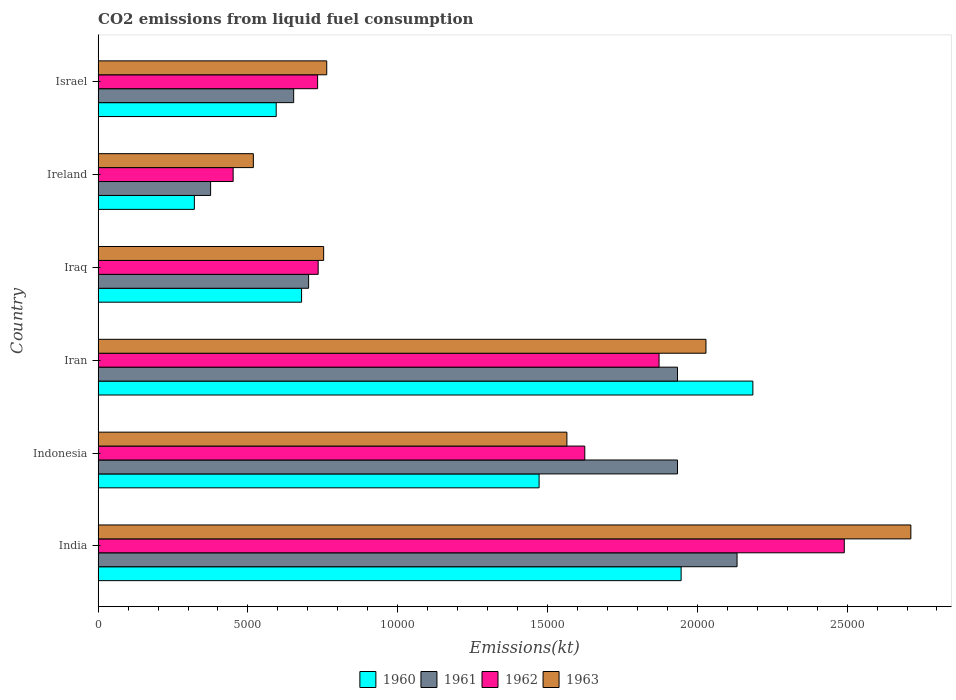How many different coloured bars are there?
Offer a very short reply. 4. How many groups of bars are there?
Provide a short and direct response. 6. How many bars are there on the 6th tick from the top?
Ensure brevity in your answer.  4. What is the label of the 4th group of bars from the top?
Offer a very short reply. Iran. In how many cases, is the number of bars for a given country not equal to the number of legend labels?
Give a very brief answer. 0. What is the amount of CO2 emitted in 1962 in Ireland?
Your answer should be compact. 4506.74. Across all countries, what is the maximum amount of CO2 emitted in 1960?
Make the answer very short. 2.19e+04. Across all countries, what is the minimum amount of CO2 emitted in 1961?
Your answer should be very brief. 3755.01. In which country was the amount of CO2 emitted in 1961 minimum?
Keep it short and to the point. Ireland. What is the total amount of CO2 emitted in 1962 in the graph?
Provide a short and direct response. 7.91e+04. What is the difference between the amount of CO2 emitted in 1963 in Indonesia and that in Iran?
Provide a succinct answer. -4642.42. What is the difference between the amount of CO2 emitted in 1962 in India and the amount of CO2 emitted in 1960 in Indonesia?
Offer a very short reply. 1.02e+04. What is the average amount of CO2 emitted in 1962 per country?
Your response must be concise. 1.32e+04. What is the difference between the amount of CO2 emitted in 1963 and amount of CO2 emitted in 1960 in Iraq?
Offer a terse response. 737.07. What is the ratio of the amount of CO2 emitted in 1961 in Iraq to that in Israel?
Provide a short and direct response. 1.08. Is the amount of CO2 emitted in 1963 in Indonesia less than that in Israel?
Your answer should be very brief. No. What is the difference between the highest and the second highest amount of CO2 emitted in 1961?
Ensure brevity in your answer.  1987.51. What is the difference between the highest and the lowest amount of CO2 emitted in 1960?
Keep it short and to the point. 1.86e+04. In how many countries, is the amount of CO2 emitted in 1960 greater than the average amount of CO2 emitted in 1960 taken over all countries?
Provide a short and direct response. 3. Is the sum of the amount of CO2 emitted in 1963 in India and Iraq greater than the maximum amount of CO2 emitted in 1962 across all countries?
Offer a terse response. Yes. Is it the case that in every country, the sum of the amount of CO2 emitted in 1962 and amount of CO2 emitted in 1960 is greater than the sum of amount of CO2 emitted in 1961 and amount of CO2 emitted in 1963?
Your answer should be very brief. No. How many bars are there?
Keep it short and to the point. 24. Are all the bars in the graph horizontal?
Your answer should be very brief. Yes. How many countries are there in the graph?
Give a very brief answer. 6. Does the graph contain grids?
Offer a terse response. No. How are the legend labels stacked?
Your response must be concise. Horizontal. What is the title of the graph?
Your response must be concise. CO2 emissions from liquid fuel consumption. What is the label or title of the X-axis?
Give a very brief answer. Emissions(kt). What is the Emissions(kt) of 1960 in India?
Give a very brief answer. 1.95e+04. What is the Emissions(kt) in 1961 in India?
Ensure brevity in your answer.  2.13e+04. What is the Emissions(kt) of 1962 in India?
Provide a succinct answer. 2.49e+04. What is the Emissions(kt) of 1963 in India?
Make the answer very short. 2.71e+04. What is the Emissions(kt) of 1960 in Indonesia?
Provide a succinct answer. 1.47e+04. What is the Emissions(kt) of 1961 in Indonesia?
Provide a succinct answer. 1.93e+04. What is the Emissions(kt) of 1962 in Indonesia?
Provide a succinct answer. 1.62e+04. What is the Emissions(kt) of 1963 in Indonesia?
Your answer should be compact. 1.56e+04. What is the Emissions(kt) of 1960 in Iran?
Offer a terse response. 2.19e+04. What is the Emissions(kt) of 1961 in Iran?
Your response must be concise. 1.93e+04. What is the Emissions(kt) in 1962 in Iran?
Offer a terse response. 1.87e+04. What is the Emissions(kt) of 1963 in Iran?
Provide a short and direct response. 2.03e+04. What is the Emissions(kt) of 1960 in Iraq?
Provide a short and direct response. 6791.28. What is the Emissions(kt) in 1961 in Iraq?
Your answer should be very brief. 7025.97. What is the Emissions(kt) of 1962 in Iraq?
Provide a succinct answer. 7345. What is the Emissions(kt) of 1963 in Iraq?
Make the answer very short. 7528.35. What is the Emissions(kt) in 1960 in Ireland?
Provide a succinct answer. 3212.29. What is the Emissions(kt) of 1961 in Ireland?
Make the answer very short. 3755.01. What is the Emissions(kt) in 1962 in Ireland?
Give a very brief answer. 4506.74. What is the Emissions(kt) in 1963 in Ireland?
Your answer should be very brief. 5181.47. What is the Emissions(kt) of 1960 in Israel?
Give a very brief answer. 5944.21. What is the Emissions(kt) in 1961 in Israel?
Offer a terse response. 6527.26. What is the Emissions(kt) of 1962 in Israel?
Give a very brief answer. 7326.67. What is the Emissions(kt) in 1963 in Israel?
Your answer should be compact. 7631.03. Across all countries, what is the maximum Emissions(kt) of 1960?
Keep it short and to the point. 2.19e+04. Across all countries, what is the maximum Emissions(kt) of 1961?
Give a very brief answer. 2.13e+04. Across all countries, what is the maximum Emissions(kt) in 1962?
Keep it short and to the point. 2.49e+04. Across all countries, what is the maximum Emissions(kt) of 1963?
Provide a short and direct response. 2.71e+04. Across all countries, what is the minimum Emissions(kt) in 1960?
Provide a short and direct response. 3212.29. Across all countries, what is the minimum Emissions(kt) in 1961?
Your answer should be compact. 3755.01. Across all countries, what is the minimum Emissions(kt) of 1962?
Your response must be concise. 4506.74. Across all countries, what is the minimum Emissions(kt) in 1963?
Your answer should be very brief. 5181.47. What is the total Emissions(kt) in 1960 in the graph?
Offer a very short reply. 7.20e+04. What is the total Emissions(kt) of 1961 in the graph?
Your answer should be very brief. 7.73e+04. What is the total Emissions(kt) of 1962 in the graph?
Your answer should be very brief. 7.91e+04. What is the total Emissions(kt) of 1963 in the graph?
Provide a short and direct response. 8.34e+04. What is the difference between the Emissions(kt) of 1960 in India and that in Indonesia?
Provide a succinct answer. 4741.43. What is the difference between the Emissions(kt) in 1961 in India and that in Indonesia?
Offer a terse response. 1987.51. What is the difference between the Emissions(kt) in 1962 in India and that in Indonesia?
Your response must be concise. 8661.45. What is the difference between the Emissions(kt) in 1963 in India and that in Indonesia?
Keep it short and to the point. 1.15e+04. What is the difference between the Emissions(kt) of 1960 in India and that in Iran?
Ensure brevity in your answer.  -2394.55. What is the difference between the Emissions(kt) of 1961 in India and that in Iran?
Offer a terse response. 1987.51. What is the difference between the Emissions(kt) of 1962 in India and that in Iran?
Keep it short and to the point. 6182.56. What is the difference between the Emissions(kt) of 1963 in India and that in Iran?
Provide a short and direct response. 6838.95. What is the difference between the Emissions(kt) of 1960 in India and that in Iraq?
Provide a succinct answer. 1.27e+04. What is the difference between the Emissions(kt) of 1961 in India and that in Iraq?
Keep it short and to the point. 1.43e+04. What is the difference between the Emissions(kt) of 1962 in India and that in Iraq?
Provide a succinct answer. 1.76e+04. What is the difference between the Emissions(kt) in 1963 in India and that in Iraq?
Provide a short and direct response. 1.96e+04. What is the difference between the Emissions(kt) in 1960 in India and that in Ireland?
Provide a short and direct response. 1.62e+04. What is the difference between the Emissions(kt) in 1961 in India and that in Ireland?
Ensure brevity in your answer.  1.76e+04. What is the difference between the Emissions(kt) in 1962 in India and that in Ireland?
Keep it short and to the point. 2.04e+04. What is the difference between the Emissions(kt) of 1963 in India and that in Ireland?
Ensure brevity in your answer.  2.19e+04. What is the difference between the Emissions(kt) of 1960 in India and that in Israel?
Your response must be concise. 1.35e+04. What is the difference between the Emissions(kt) in 1961 in India and that in Israel?
Keep it short and to the point. 1.48e+04. What is the difference between the Emissions(kt) in 1962 in India and that in Israel?
Make the answer very short. 1.76e+04. What is the difference between the Emissions(kt) of 1963 in India and that in Israel?
Ensure brevity in your answer.  1.95e+04. What is the difference between the Emissions(kt) in 1960 in Indonesia and that in Iran?
Give a very brief answer. -7135.98. What is the difference between the Emissions(kt) of 1962 in Indonesia and that in Iran?
Provide a short and direct response. -2478.89. What is the difference between the Emissions(kt) in 1963 in Indonesia and that in Iran?
Keep it short and to the point. -4642.42. What is the difference between the Emissions(kt) of 1960 in Indonesia and that in Iraq?
Ensure brevity in your answer.  7928.05. What is the difference between the Emissions(kt) of 1961 in Indonesia and that in Iraq?
Your response must be concise. 1.23e+04. What is the difference between the Emissions(kt) of 1962 in Indonesia and that in Iraq?
Make the answer very short. 8899.81. What is the difference between the Emissions(kt) of 1963 in Indonesia and that in Iraq?
Your answer should be compact. 8118.74. What is the difference between the Emissions(kt) in 1960 in Indonesia and that in Ireland?
Your response must be concise. 1.15e+04. What is the difference between the Emissions(kt) of 1961 in Indonesia and that in Ireland?
Your answer should be very brief. 1.56e+04. What is the difference between the Emissions(kt) in 1962 in Indonesia and that in Ireland?
Your answer should be compact. 1.17e+04. What is the difference between the Emissions(kt) in 1963 in Indonesia and that in Ireland?
Make the answer very short. 1.05e+04. What is the difference between the Emissions(kt) in 1960 in Indonesia and that in Israel?
Your answer should be compact. 8775.13. What is the difference between the Emissions(kt) in 1961 in Indonesia and that in Israel?
Your response must be concise. 1.28e+04. What is the difference between the Emissions(kt) of 1962 in Indonesia and that in Israel?
Offer a very short reply. 8918.14. What is the difference between the Emissions(kt) in 1963 in Indonesia and that in Israel?
Keep it short and to the point. 8016.06. What is the difference between the Emissions(kt) in 1960 in Iran and that in Iraq?
Ensure brevity in your answer.  1.51e+04. What is the difference between the Emissions(kt) of 1961 in Iran and that in Iraq?
Keep it short and to the point. 1.23e+04. What is the difference between the Emissions(kt) of 1962 in Iran and that in Iraq?
Give a very brief answer. 1.14e+04. What is the difference between the Emissions(kt) of 1963 in Iran and that in Iraq?
Your answer should be very brief. 1.28e+04. What is the difference between the Emissions(kt) of 1960 in Iran and that in Ireland?
Provide a short and direct response. 1.86e+04. What is the difference between the Emissions(kt) of 1961 in Iran and that in Ireland?
Ensure brevity in your answer.  1.56e+04. What is the difference between the Emissions(kt) of 1962 in Iran and that in Ireland?
Provide a succinct answer. 1.42e+04. What is the difference between the Emissions(kt) of 1963 in Iran and that in Ireland?
Offer a terse response. 1.51e+04. What is the difference between the Emissions(kt) of 1960 in Iran and that in Israel?
Your answer should be compact. 1.59e+04. What is the difference between the Emissions(kt) of 1961 in Iran and that in Israel?
Make the answer very short. 1.28e+04. What is the difference between the Emissions(kt) of 1962 in Iran and that in Israel?
Offer a terse response. 1.14e+04. What is the difference between the Emissions(kt) in 1963 in Iran and that in Israel?
Your answer should be very brief. 1.27e+04. What is the difference between the Emissions(kt) of 1960 in Iraq and that in Ireland?
Provide a short and direct response. 3578.99. What is the difference between the Emissions(kt) in 1961 in Iraq and that in Ireland?
Offer a very short reply. 3270.96. What is the difference between the Emissions(kt) of 1962 in Iraq and that in Ireland?
Provide a succinct answer. 2838.26. What is the difference between the Emissions(kt) of 1963 in Iraq and that in Ireland?
Offer a terse response. 2346.88. What is the difference between the Emissions(kt) of 1960 in Iraq and that in Israel?
Your response must be concise. 847.08. What is the difference between the Emissions(kt) in 1961 in Iraq and that in Israel?
Make the answer very short. 498.71. What is the difference between the Emissions(kt) in 1962 in Iraq and that in Israel?
Provide a succinct answer. 18.34. What is the difference between the Emissions(kt) in 1963 in Iraq and that in Israel?
Your response must be concise. -102.68. What is the difference between the Emissions(kt) of 1960 in Ireland and that in Israel?
Provide a short and direct response. -2731.91. What is the difference between the Emissions(kt) of 1961 in Ireland and that in Israel?
Your answer should be very brief. -2772.25. What is the difference between the Emissions(kt) of 1962 in Ireland and that in Israel?
Your response must be concise. -2819.92. What is the difference between the Emissions(kt) in 1963 in Ireland and that in Israel?
Offer a very short reply. -2449.56. What is the difference between the Emissions(kt) of 1960 in India and the Emissions(kt) of 1961 in Indonesia?
Your answer should be very brief. 121.01. What is the difference between the Emissions(kt) of 1960 in India and the Emissions(kt) of 1962 in Indonesia?
Provide a short and direct response. 3215.96. What is the difference between the Emissions(kt) of 1960 in India and the Emissions(kt) of 1963 in Indonesia?
Your answer should be very brief. 3813.68. What is the difference between the Emissions(kt) of 1961 in India and the Emissions(kt) of 1962 in Indonesia?
Provide a short and direct response. 5082.46. What is the difference between the Emissions(kt) of 1961 in India and the Emissions(kt) of 1963 in Indonesia?
Your answer should be compact. 5680.18. What is the difference between the Emissions(kt) in 1962 in India and the Emissions(kt) in 1963 in Indonesia?
Offer a very short reply. 9259.17. What is the difference between the Emissions(kt) of 1960 in India and the Emissions(kt) of 1961 in Iran?
Offer a terse response. 121.01. What is the difference between the Emissions(kt) in 1960 in India and the Emissions(kt) in 1962 in Iran?
Provide a succinct answer. 737.07. What is the difference between the Emissions(kt) of 1960 in India and the Emissions(kt) of 1963 in Iran?
Your answer should be very brief. -828.74. What is the difference between the Emissions(kt) in 1961 in India and the Emissions(kt) in 1962 in Iran?
Keep it short and to the point. 2603.57. What is the difference between the Emissions(kt) in 1961 in India and the Emissions(kt) in 1963 in Iran?
Keep it short and to the point. 1037.76. What is the difference between the Emissions(kt) in 1962 in India and the Emissions(kt) in 1963 in Iran?
Give a very brief answer. 4616.75. What is the difference between the Emissions(kt) of 1960 in India and the Emissions(kt) of 1961 in Iraq?
Give a very brief answer. 1.24e+04. What is the difference between the Emissions(kt) of 1960 in India and the Emissions(kt) of 1962 in Iraq?
Make the answer very short. 1.21e+04. What is the difference between the Emissions(kt) in 1960 in India and the Emissions(kt) in 1963 in Iraq?
Ensure brevity in your answer.  1.19e+04. What is the difference between the Emissions(kt) of 1961 in India and the Emissions(kt) of 1962 in Iraq?
Your answer should be very brief. 1.40e+04. What is the difference between the Emissions(kt) of 1961 in India and the Emissions(kt) of 1963 in Iraq?
Keep it short and to the point. 1.38e+04. What is the difference between the Emissions(kt) in 1962 in India and the Emissions(kt) in 1963 in Iraq?
Keep it short and to the point. 1.74e+04. What is the difference between the Emissions(kt) of 1960 in India and the Emissions(kt) of 1961 in Ireland?
Your answer should be compact. 1.57e+04. What is the difference between the Emissions(kt) of 1960 in India and the Emissions(kt) of 1962 in Ireland?
Provide a short and direct response. 1.50e+04. What is the difference between the Emissions(kt) in 1960 in India and the Emissions(kt) in 1963 in Ireland?
Your answer should be compact. 1.43e+04. What is the difference between the Emissions(kt) in 1961 in India and the Emissions(kt) in 1962 in Ireland?
Ensure brevity in your answer.  1.68e+04. What is the difference between the Emissions(kt) in 1961 in India and the Emissions(kt) in 1963 in Ireland?
Offer a very short reply. 1.61e+04. What is the difference between the Emissions(kt) in 1962 in India and the Emissions(kt) in 1963 in Ireland?
Your response must be concise. 1.97e+04. What is the difference between the Emissions(kt) in 1960 in India and the Emissions(kt) in 1961 in Israel?
Your answer should be compact. 1.29e+04. What is the difference between the Emissions(kt) in 1960 in India and the Emissions(kt) in 1962 in Israel?
Make the answer very short. 1.21e+04. What is the difference between the Emissions(kt) of 1960 in India and the Emissions(kt) of 1963 in Israel?
Give a very brief answer. 1.18e+04. What is the difference between the Emissions(kt) in 1961 in India and the Emissions(kt) in 1962 in Israel?
Ensure brevity in your answer.  1.40e+04. What is the difference between the Emissions(kt) of 1961 in India and the Emissions(kt) of 1963 in Israel?
Your answer should be compact. 1.37e+04. What is the difference between the Emissions(kt) of 1962 in India and the Emissions(kt) of 1963 in Israel?
Provide a succinct answer. 1.73e+04. What is the difference between the Emissions(kt) in 1960 in Indonesia and the Emissions(kt) in 1961 in Iran?
Ensure brevity in your answer.  -4620.42. What is the difference between the Emissions(kt) of 1960 in Indonesia and the Emissions(kt) of 1962 in Iran?
Offer a terse response. -4004.36. What is the difference between the Emissions(kt) in 1960 in Indonesia and the Emissions(kt) in 1963 in Iran?
Offer a very short reply. -5570.17. What is the difference between the Emissions(kt) of 1961 in Indonesia and the Emissions(kt) of 1962 in Iran?
Keep it short and to the point. 616.06. What is the difference between the Emissions(kt) in 1961 in Indonesia and the Emissions(kt) in 1963 in Iran?
Ensure brevity in your answer.  -949.75. What is the difference between the Emissions(kt) of 1962 in Indonesia and the Emissions(kt) of 1963 in Iran?
Your response must be concise. -4044.7. What is the difference between the Emissions(kt) in 1960 in Indonesia and the Emissions(kt) in 1961 in Iraq?
Your response must be concise. 7693.37. What is the difference between the Emissions(kt) of 1960 in Indonesia and the Emissions(kt) of 1962 in Iraq?
Ensure brevity in your answer.  7374.34. What is the difference between the Emissions(kt) in 1960 in Indonesia and the Emissions(kt) in 1963 in Iraq?
Provide a succinct answer. 7190.99. What is the difference between the Emissions(kt) of 1961 in Indonesia and the Emissions(kt) of 1962 in Iraq?
Ensure brevity in your answer.  1.20e+04. What is the difference between the Emissions(kt) in 1961 in Indonesia and the Emissions(kt) in 1963 in Iraq?
Offer a terse response. 1.18e+04. What is the difference between the Emissions(kt) of 1962 in Indonesia and the Emissions(kt) of 1963 in Iraq?
Provide a short and direct response. 8716.46. What is the difference between the Emissions(kt) in 1960 in Indonesia and the Emissions(kt) in 1961 in Ireland?
Ensure brevity in your answer.  1.10e+04. What is the difference between the Emissions(kt) in 1960 in Indonesia and the Emissions(kt) in 1962 in Ireland?
Your response must be concise. 1.02e+04. What is the difference between the Emissions(kt) of 1960 in Indonesia and the Emissions(kt) of 1963 in Ireland?
Your response must be concise. 9537.87. What is the difference between the Emissions(kt) in 1961 in Indonesia and the Emissions(kt) in 1962 in Ireland?
Your answer should be compact. 1.48e+04. What is the difference between the Emissions(kt) in 1961 in Indonesia and the Emissions(kt) in 1963 in Ireland?
Provide a short and direct response. 1.42e+04. What is the difference between the Emissions(kt) in 1962 in Indonesia and the Emissions(kt) in 1963 in Ireland?
Your answer should be very brief. 1.11e+04. What is the difference between the Emissions(kt) of 1960 in Indonesia and the Emissions(kt) of 1961 in Israel?
Offer a terse response. 8192.08. What is the difference between the Emissions(kt) in 1960 in Indonesia and the Emissions(kt) in 1962 in Israel?
Your response must be concise. 7392.67. What is the difference between the Emissions(kt) in 1960 in Indonesia and the Emissions(kt) in 1963 in Israel?
Give a very brief answer. 7088.31. What is the difference between the Emissions(kt) in 1961 in Indonesia and the Emissions(kt) in 1962 in Israel?
Offer a very short reply. 1.20e+04. What is the difference between the Emissions(kt) of 1961 in Indonesia and the Emissions(kt) of 1963 in Israel?
Provide a short and direct response. 1.17e+04. What is the difference between the Emissions(kt) of 1962 in Indonesia and the Emissions(kt) of 1963 in Israel?
Your response must be concise. 8613.78. What is the difference between the Emissions(kt) of 1960 in Iran and the Emissions(kt) of 1961 in Iraq?
Provide a succinct answer. 1.48e+04. What is the difference between the Emissions(kt) in 1960 in Iran and the Emissions(kt) in 1962 in Iraq?
Your response must be concise. 1.45e+04. What is the difference between the Emissions(kt) of 1960 in Iran and the Emissions(kt) of 1963 in Iraq?
Offer a very short reply. 1.43e+04. What is the difference between the Emissions(kt) in 1961 in Iran and the Emissions(kt) in 1962 in Iraq?
Your response must be concise. 1.20e+04. What is the difference between the Emissions(kt) of 1961 in Iran and the Emissions(kt) of 1963 in Iraq?
Give a very brief answer. 1.18e+04. What is the difference between the Emissions(kt) of 1962 in Iran and the Emissions(kt) of 1963 in Iraq?
Make the answer very short. 1.12e+04. What is the difference between the Emissions(kt) of 1960 in Iran and the Emissions(kt) of 1961 in Ireland?
Provide a succinct answer. 1.81e+04. What is the difference between the Emissions(kt) of 1960 in Iran and the Emissions(kt) of 1962 in Ireland?
Offer a terse response. 1.73e+04. What is the difference between the Emissions(kt) of 1960 in Iran and the Emissions(kt) of 1963 in Ireland?
Your response must be concise. 1.67e+04. What is the difference between the Emissions(kt) of 1961 in Iran and the Emissions(kt) of 1962 in Ireland?
Ensure brevity in your answer.  1.48e+04. What is the difference between the Emissions(kt) in 1961 in Iran and the Emissions(kt) in 1963 in Ireland?
Your response must be concise. 1.42e+04. What is the difference between the Emissions(kt) in 1962 in Iran and the Emissions(kt) in 1963 in Ireland?
Give a very brief answer. 1.35e+04. What is the difference between the Emissions(kt) of 1960 in Iran and the Emissions(kt) of 1961 in Israel?
Keep it short and to the point. 1.53e+04. What is the difference between the Emissions(kt) in 1960 in Iran and the Emissions(kt) in 1962 in Israel?
Provide a succinct answer. 1.45e+04. What is the difference between the Emissions(kt) of 1960 in Iran and the Emissions(kt) of 1963 in Israel?
Your answer should be compact. 1.42e+04. What is the difference between the Emissions(kt) of 1961 in Iran and the Emissions(kt) of 1962 in Israel?
Offer a terse response. 1.20e+04. What is the difference between the Emissions(kt) of 1961 in Iran and the Emissions(kt) of 1963 in Israel?
Keep it short and to the point. 1.17e+04. What is the difference between the Emissions(kt) in 1962 in Iran and the Emissions(kt) in 1963 in Israel?
Your answer should be very brief. 1.11e+04. What is the difference between the Emissions(kt) in 1960 in Iraq and the Emissions(kt) in 1961 in Ireland?
Keep it short and to the point. 3036.28. What is the difference between the Emissions(kt) of 1960 in Iraq and the Emissions(kt) of 1962 in Ireland?
Your response must be concise. 2284.54. What is the difference between the Emissions(kt) of 1960 in Iraq and the Emissions(kt) of 1963 in Ireland?
Offer a very short reply. 1609.81. What is the difference between the Emissions(kt) of 1961 in Iraq and the Emissions(kt) of 1962 in Ireland?
Your response must be concise. 2519.23. What is the difference between the Emissions(kt) in 1961 in Iraq and the Emissions(kt) in 1963 in Ireland?
Keep it short and to the point. 1844.5. What is the difference between the Emissions(kt) of 1962 in Iraq and the Emissions(kt) of 1963 in Ireland?
Offer a very short reply. 2163.53. What is the difference between the Emissions(kt) of 1960 in Iraq and the Emissions(kt) of 1961 in Israel?
Your response must be concise. 264.02. What is the difference between the Emissions(kt) of 1960 in Iraq and the Emissions(kt) of 1962 in Israel?
Your response must be concise. -535.38. What is the difference between the Emissions(kt) in 1960 in Iraq and the Emissions(kt) in 1963 in Israel?
Provide a succinct answer. -839.74. What is the difference between the Emissions(kt) of 1961 in Iraq and the Emissions(kt) of 1962 in Israel?
Your answer should be very brief. -300.69. What is the difference between the Emissions(kt) in 1961 in Iraq and the Emissions(kt) in 1963 in Israel?
Offer a very short reply. -605.05. What is the difference between the Emissions(kt) of 1962 in Iraq and the Emissions(kt) of 1963 in Israel?
Offer a terse response. -286.03. What is the difference between the Emissions(kt) in 1960 in Ireland and the Emissions(kt) in 1961 in Israel?
Provide a succinct answer. -3314.97. What is the difference between the Emissions(kt) in 1960 in Ireland and the Emissions(kt) in 1962 in Israel?
Provide a succinct answer. -4114.37. What is the difference between the Emissions(kt) of 1960 in Ireland and the Emissions(kt) of 1963 in Israel?
Give a very brief answer. -4418.73. What is the difference between the Emissions(kt) of 1961 in Ireland and the Emissions(kt) of 1962 in Israel?
Make the answer very short. -3571.66. What is the difference between the Emissions(kt) in 1961 in Ireland and the Emissions(kt) in 1963 in Israel?
Make the answer very short. -3876.02. What is the difference between the Emissions(kt) of 1962 in Ireland and the Emissions(kt) of 1963 in Israel?
Ensure brevity in your answer.  -3124.28. What is the average Emissions(kt) of 1960 per country?
Keep it short and to the point. 1.20e+04. What is the average Emissions(kt) of 1961 per country?
Make the answer very short. 1.29e+04. What is the average Emissions(kt) of 1962 per country?
Provide a short and direct response. 1.32e+04. What is the average Emissions(kt) in 1963 per country?
Your answer should be very brief. 1.39e+04. What is the difference between the Emissions(kt) of 1960 and Emissions(kt) of 1961 in India?
Ensure brevity in your answer.  -1866.5. What is the difference between the Emissions(kt) of 1960 and Emissions(kt) of 1962 in India?
Keep it short and to the point. -5445.49. What is the difference between the Emissions(kt) in 1960 and Emissions(kt) in 1963 in India?
Your answer should be very brief. -7667.7. What is the difference between the Emissions(kt) of 1961 and Emissions(kt) of 1962 in India?
Ensure brevity in your answer.  -3578.99. What is the difference between the Emissions(kt) in 1961 and Emissions(kt) in 1963 in India?
Your answer should be compact. -5801.19. What is the difference between the Emissions(kt) of 1962 and Emissions(kt) of 1963 in India?
Provide a succinct answer. -2222.2. What is the difference between the Emissions(kt) of 1960 and Emissions(kt) of 1961 in Indonesia?
Offer a very short reply. -4620.42. What is the difference between the Emissions(kt) in 1960 and Emissions(kt) in 1962 in Indonesia?
Your response must be concise. -1525.47. What is the difference between the Emissions(kt) of 1960 and Emissions(kt) of 1963 in Indonesia?
Your answer should be compact. -927.75. What is the difference between the Emissions(kt) in 1961 and Emissions(kt) in 1962 in Indonesia?
Your response must be concise. 3094.95. What is the difference between the Emissions(kt) of 1961 and Emissions(kt) of 1963 in Indonesia?
Give a very brief answer. 3692.67. What is the difference between the Emissions(kt) of 1962 and Emissions(kt) of 1963 in Indonesia?
Make the answer very short. 597.72. What is the difference between the Emissions(kt) of 1960 and Emissions(kt) of 1961 in Iran?
Provide a short and direct response. 2515.56. What is the difference between the Emissions(kt) of 1960 and Emissions(kt) of 1962 in Iran?
Ensure brevity in your answer.  3131.62. What is the difference between the Emissions(kt) in 1960 and Emissions(kt) in 1963 in Iran?
Ensure brevity in your answer.  1565.81. What is the difference between the Emissions(kt) of 1961 and Emissions(kt) of 1962 in Iran?
Make the answer very short. 616.06. What is the difference between the Emissions(kt) in 1961 and Emissions(kt) in 1963 in Iran?
Ensure brevity in your answer.  -949.75. What is the difference between the Emissions(kt) in 1962 and Emissions(kt) in 1963 in Iran?
Your response must be concise. -1565.81. What is the difference between the Emissions(kt) of 1960 and Emissions(kt) of 1961 in Iraq?
Your response must be concise. -234.69. What is the difference between the Emissions(kt) of 1960 and Emissions(kt) of 1962 in Iraq?
Your answer should be compact. -553.72. What is the difference between the Emissions(kt) in 1960 and Emissions(kt) in 1963 in Iraq?
Provide a short and direct response. -737.07. What is the difference between the Emissions(kt) of 1961 and Emissions(kt) of 1962 in Iraq?
Make the answer very short. -319.03. What is the difference between the Emissions(kt) in 1961 and Emissions(kt) in 1963 in Iraq?
Keep it short and to the point. -502.38. What is the difference between the Emissions(kt) of 1962 and Emissions(kt) of 1963 in Iraq?
Provide a succinct answer. -183.35. What is the difference between the Emissions(kt) of 1960 and Emissions(kt) of 1961 in Ireland?
Give a very brief answer. -542.72. What is the difference between the Emissions(kt) of 1960 and Emissions(kt) of 1962 in Ireland?
Ensure brevity in your answer.  -1294.45. What is the difference between the Emissions(kt) of 1960 and Emissions(kt) of 1963 in Ireland?
Keep it short and to the point. -1969.18. What is the difference between the Emissions(kt) in 1961 and Emissions(kt) in 1962 in Ireland?
Offer a very short reply. -751.74. What is the difference between the Emissions(kt) in 1961 and Emissions(kt) in 1963 in Ireland?
Your response must be concise. -1426.46. What is the difference between the Emissions(kt) of 1962 and Emissions(kt) of 1963 in Ireland?
Provide a short and direct response. -674.73. What is the difference between the Emissions(kt) of 1960 and Emissions(kt) of 1961 in Israel?
Offer a very short reply. -583.05. What is the difference between the Emissions(kt) in 1960 and Emissions(kt) in 1962 in Israel?
Ensure brevity in your answer.  -1382.46. What is the difference between the Emissions(kt) of 1960 and Emissions(kt) of 1963 in Israel?
Ensure brevity in your answer.  -1686.82. What is the difference between the Emissions(kt) in 1961 and Emissions(kt) in 1962 in Israel?
Your answer should be very brief. -799.41. What is the difference between the Emissions(kt) in 1961 and Emissions(kt) in 1963 in Israel?
Your response must be concise. -1103.77. What is the difference between the Emissions(kt) of 1962 and Emissions(kt) of 1963 in Israel?
Make the answer very short. -304.36. What is the ratio of the Emissions(kt) of 1960 in India to that in Indonesia?
Your response must be concise. 1.32. What is the ratio of the Emissions(kt) in 1961 in India to that in Indonesia?
Keep it short and to the point. 1.1. What is the ratio of the Emissions(kt) of 1962 in India to that in Indonesia?
Offer a very short reply. 1.53. What is the ratio of the Emissions(kt) of 1963 in India to that in Indonesia?
Provide a short and direct response. 1.73. What is the ratio of the Emissions(kt) in 1960 in India to that in Iran?
Your answer should be compact. 0.89. What is the ratio of the Emissions(kt) of 1961 in India to that in Iran?
Make the answer very short. 1.1. What is the ratio of the Emissions(kt) in 1962 in India to that in Iran?
Give a very brief answer. 1.33. What is the ratio of the Emissions(kt) in 1963 in India to that in Iran?
Offer a very short reply. 1.34. What is the ratio of the Emissions(kt) in 1960 in India to that in Iraq?
Ensure brevity in your answer.  2.87. What is the ratio of the Emissions(kt) of 1961 in India to that in Iraq?
Provide a short and direct response. 3.04. What is the ratio of the Emissions(kt) of 1962 in India to that in Iraq?
Keep it short and to the point. 3.39. What is the ratio of the Emissions(kt) of 1963 in India to that in Iraq?
Make the answer very short. 3.6. What is the ratio of the Emissions(kt) in 1960 in India to that in Ireland?
Ensure brevity in your answer.  6.06. What is the ratio of the Emissions(kt) of 1961 in India to that in Ireland?
Your response must be concise. 5.68. What is the ratio of the Emissions(kt) of 1962 in India to that in Ireland?
Provide a succinct answer. 5.53. What is the ratio of the Emissions(kt) in 1963 in India to that in Ireland?
Provide a succinct answer. 5.24. What is the ratio of the Emissions(kt) of 1960 in India to that in Israel?
Provide a short and direct response. 3.27. What is the ratio of the Emissions(kt) of 1961 in India to that in Israel?
Your answer should be compact. 3.27. What is the ratio of the Emissions(kt) of 1962 in India to that in Israel?
Ensure brevity in your answer.  3.4. What is the ratio of the Emissions(kt) in 1963 in India to that in Israel?
Provide a succinct answer. 3.56. What is the ratio of the Emissions(kt) of 1960 in Indonesia to that in Iran?
Provide a short and direct response. 0.67. What is the ratio of the Emissions(kt) of 1961 in Indonesia to that in Iran?
Ensure brevity in your answer.  1. What is the ratio of the Emissions(kt) of 1962 in Indonesia to that in Iran?
Offer a very short reply. 0.87. What is the ratio of the Emissions(kt) of 1963 in Indonesia to that in Iran?
Offer a terse response. 0.77. What is the ratio of the Emissions(kt) in 1960 in Indonesia to that in Iraq?
Provide a succinct answer. 2.17. What is the ratio of the Emissions(kt) of 1961 in Indonesia to that in Iraq?
Keep it short and to the point. 2.75. What is the ratio of the Emissions(kt) in 1962 in Indonesia to that in Iraq?
Give a very brief answer. 2.21. What is the ratio of the Emissions(kt) in 1963 in Indonesia to that in Iraq?
Give a very brief answer. 2.08. What is the ratio of the Emissions(kt) of 1960 in Indonesia to that in Ireland?
Your answer should be compact. 4.58. What is the ratio of the Emissions(kt) in 1961 in Indonesia to that in Ireland?
Provide a short and direct response. 5.15. What is the ratio of the Emissions(kt) in 1962 in Indonesia to that in Ireland?
Give a very brief answer. 3.6. What is the ratio of the Emissions(kt) of 1963 in Indonesia to that in Ireland?
Provide a succinct answer. 3.02. What is the ratio of the Emissions(kt) in 1960 in Indonesia to that in Israel?
Your answer should be very brief. 2.48. What is the ratio of the Emissions(kt) in 1961 in Indonesia to that in Israel?
Make the answer very short. 2.96. What is the ratio of the Emissions(kt) of 1962 in Indonesia to that in Israel?
Your response must be concise. 2.22. What is the ratio of the Emissions(kt) in 1963 in Indonesia to that in Israel?
Make the answer very short. 2.05. What is the ratio of the Emissions(kt) in 1960 in Iran to that in Iraq?
Offer a terse response. 3.22. What is the ratio of the Emissions(kt) of 1961 in Iran to that in Iraq?
Offer a very short reply. 2.75. What is the ratio of the Emissions(kt) in 1962 in Iran to that in Iraq?
Your answer should be compact. 2.55. What is the ratio of the Emissions(kt) of 1963 in Iran to that in Iraq?
Provide a succinct answer. 2.7. What is the ratio of the Emissions(kt) of 1960 in Iran to that in Ireland?
Keep it short and to the point. 6.8. What is the ratio of the Emissions(kt) of 1961 in Iran to that in Ireland?
Ensure brevity in your answer.  5.15. What is the ratio of the Emissions(kt) in 1962 in Iran to that in Ireland?
Offer a very short reply. 4.15. What is the ratio of the Emissions(kt) of 1963 in Iran to that in Ireland?
Offer a terse response. 3.92. What is the ratio of the Emissions(kt) of 1960 in Iran to that in Israel?
Give a very brief answer. 3.68. What is the ratio of the Emissions(kt) of 1961 in Iran to that in Israel?
Provide a succinct answer. 2.96. What is the ratio of the Emissions(kt) in 1962 in Iran to that in Israel?
Your answer should be compact. 2.56. What is the ratio of the Emissions(kt) of 1963 in Iran to that in Israel?
Your response must be concise. 2.66. What is the ratio of the Emissions(kt) in 1960 in Iraq to that in Ireland?
Your response must be concise. 2.11. What is the ratio of the Emissions(kt) of 1961 in Iraq to that in Ireland?
Offer a very short reply. 1.87. What is the ratio of the Emissions(kt) in 1962 in Iraq to that in Ireland?
Ensure brevity in your answer.  1.63. What is the ratio of the Emissions(kt) in 1963 in Iraq to that in Ireland?
Your response must be concise. 1.45. What is the ratio of the Emissions(kt) of 1960 in Iraq to that in Israel?
Provide a succinct answer. 1.14. What is the ratio of the Emissions(kt) of 1961 in Iraq to that in Israel?
Offer a very short reply. 1.08. What is the ratio of the Emissions(kt) of 1963 in Iraq to that in Israel?
Your response must be concise. 0.99. What is the ratio of the Emissions(kt) in 1960 in Ireland to that in Israel?
Offer a very short reply. 0.54. What is the ratio of the Emissions(kt) in 1961 in Ireland to that in Israel?
Give a very brief answer. 0.58. What is the ratio of the Emissions(kt) in 1962 in Ireland to that in Israel?
Provide a short and direct response. 0.62. What is the ratio of the Emissions(kt) of 1963 in Ireland to that in Israel?
Your answer should be very brief. 0.68. What is the difference between the highest and the second highest Emissions(kt) in 1960?
Offer a very short reply. 2394.55. What is the difference between the highest and the second highest Emissions(kt) of 1961?
Ensure brevity in your answer.  1987.51. What is the difference between the highest and the second highest Emissions(kt) in 1962?
Offer a terse response. 6182.56. What is the difference between the highest and the second highest Emissions(kt) in 1963?
Your response must be concise. 6838.95. What is the difference between the highest and the lowest Emissions(kt) of 1960?
Offer a very short reply. 1.86e+04. What is the difference between the highest and the lowest Emissions(kt) in 1961?
Keep it short and to the point. 1.76e+04. What is the difference between the highest and the lowest Emissions(kt) of 1962?
Provide a succinct answer. 2.04e+04. What is the difference between the highest and the lowest Emissions(kt) of 1963?
Make the answer very short. 2.19e+04. 